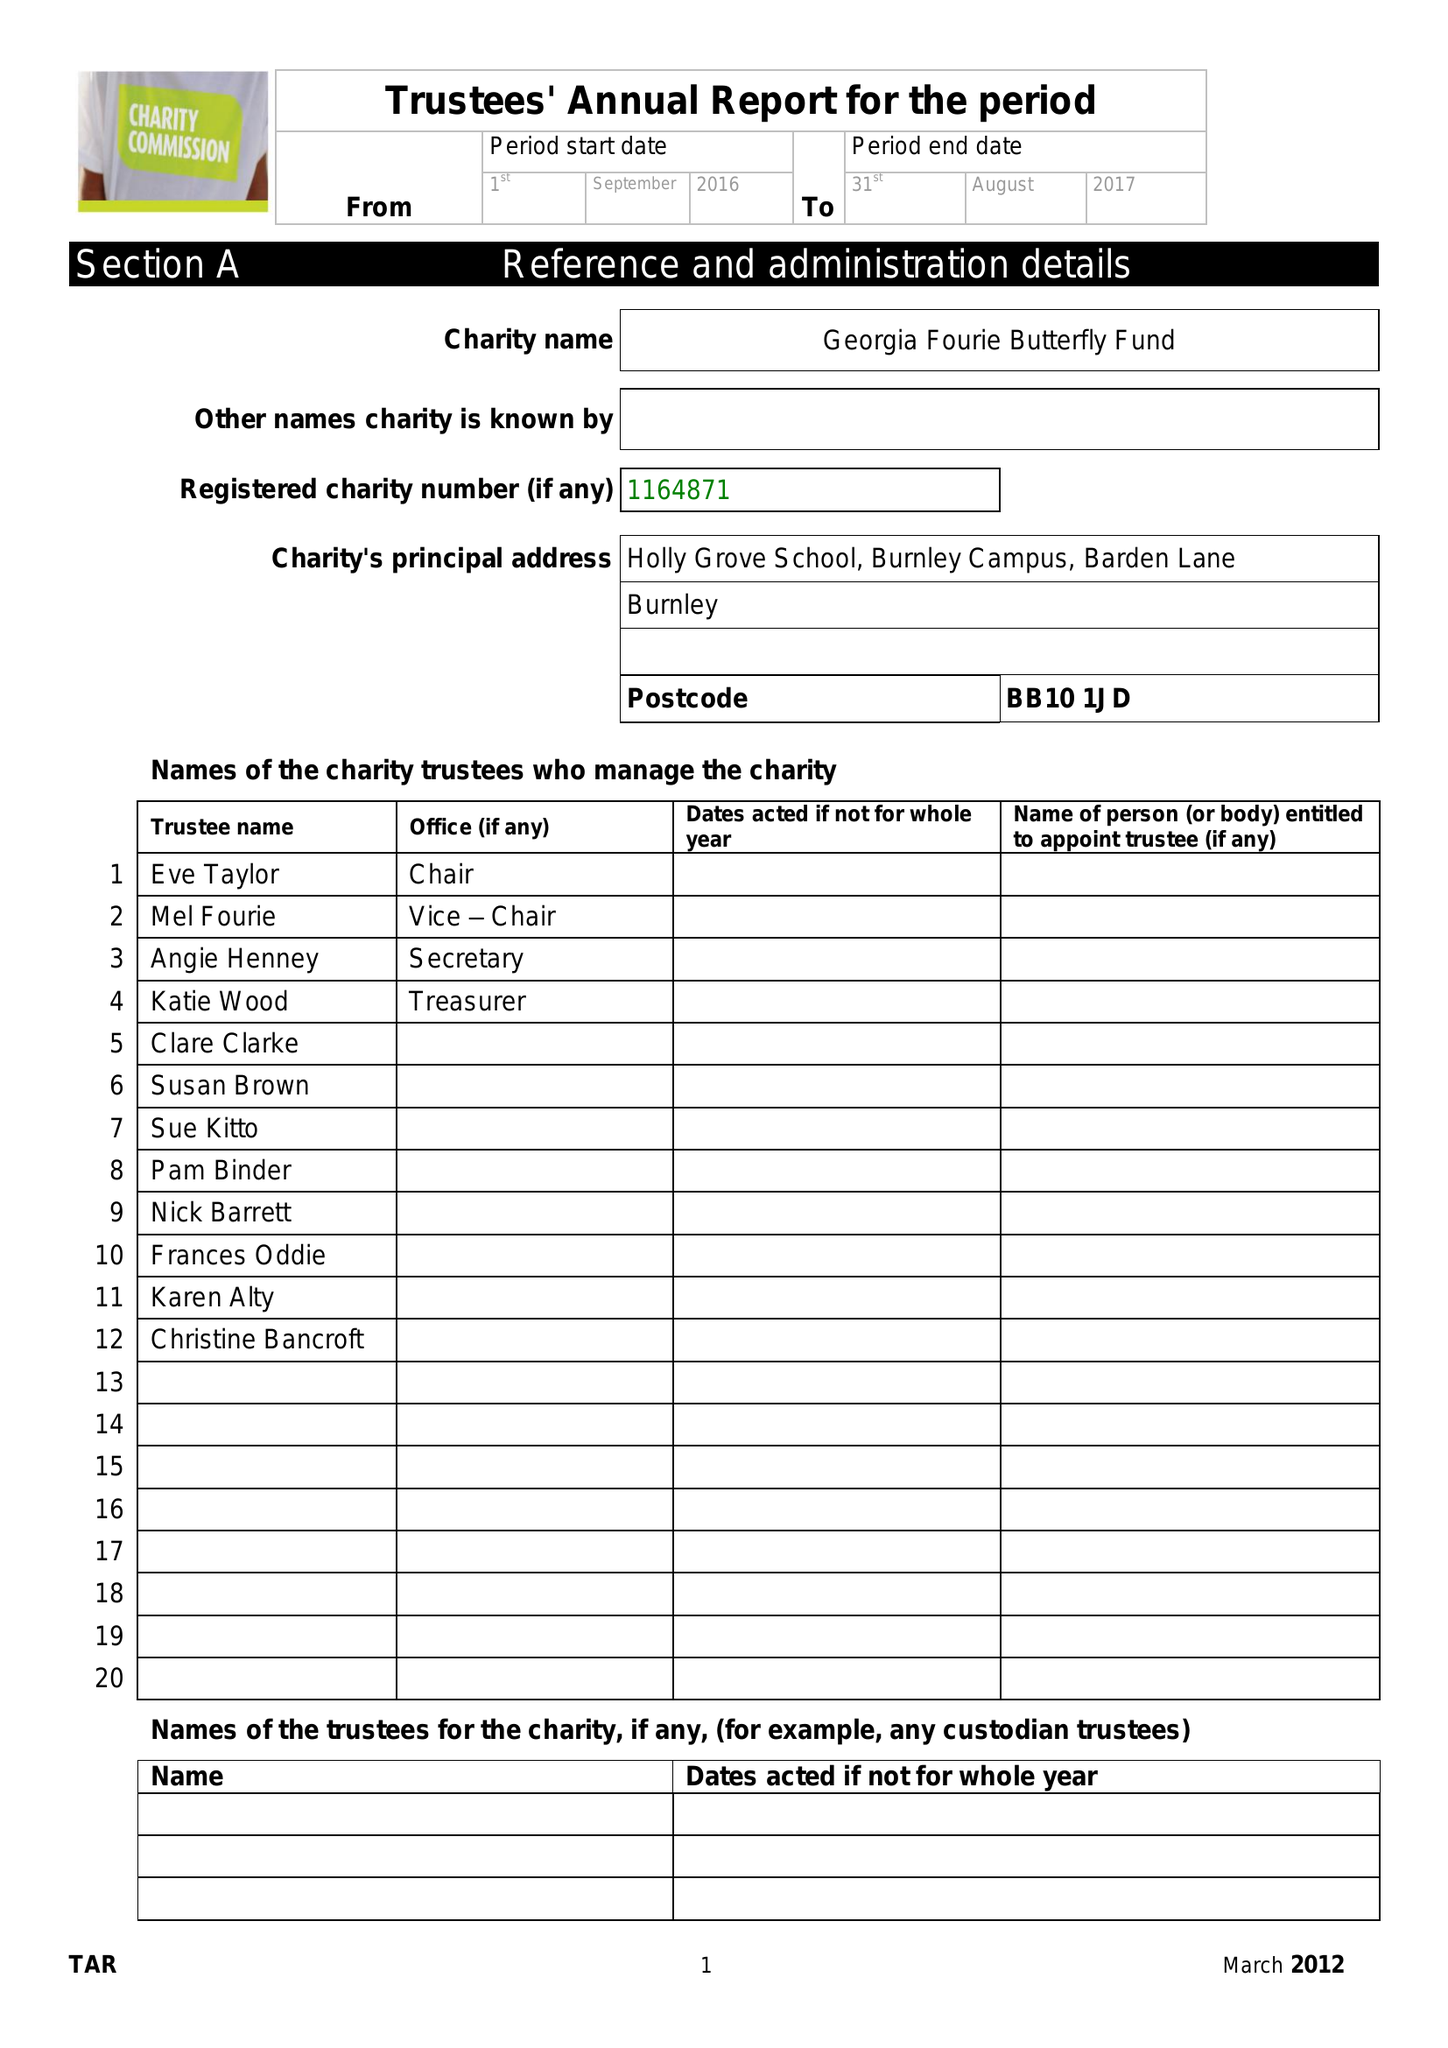What is the value for the address__postcode?
Answer the question using a single word or phrase. BB10 1JD 